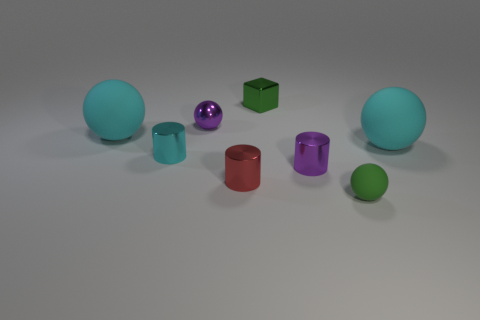How many cyan balls must be subtracted to get 1 cyan balls? 1 Subtract all rubber spheres. How many spheres are left? 1 Subtract all gray blocks. How many cyan balls are left? 2 Subtract all purple balls. How many balls are left? 3 Add 1 tiny green shiny cubes. How many objects exist? 9 Subtract all red spheres. Subtract all yellow cubes. How many spheres are left? 4 Subtract all cubes. How many objects are left? 7 Subtract all small cubes. Subtract all small purple balls. How many objects are left? 6 Add 1 large cyan matte things. How many large cyan matte things are left? 3 Add 6 small red cylinders. How many small red cylinders exist? 7 